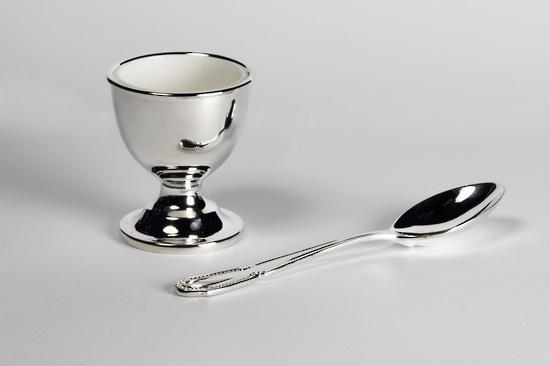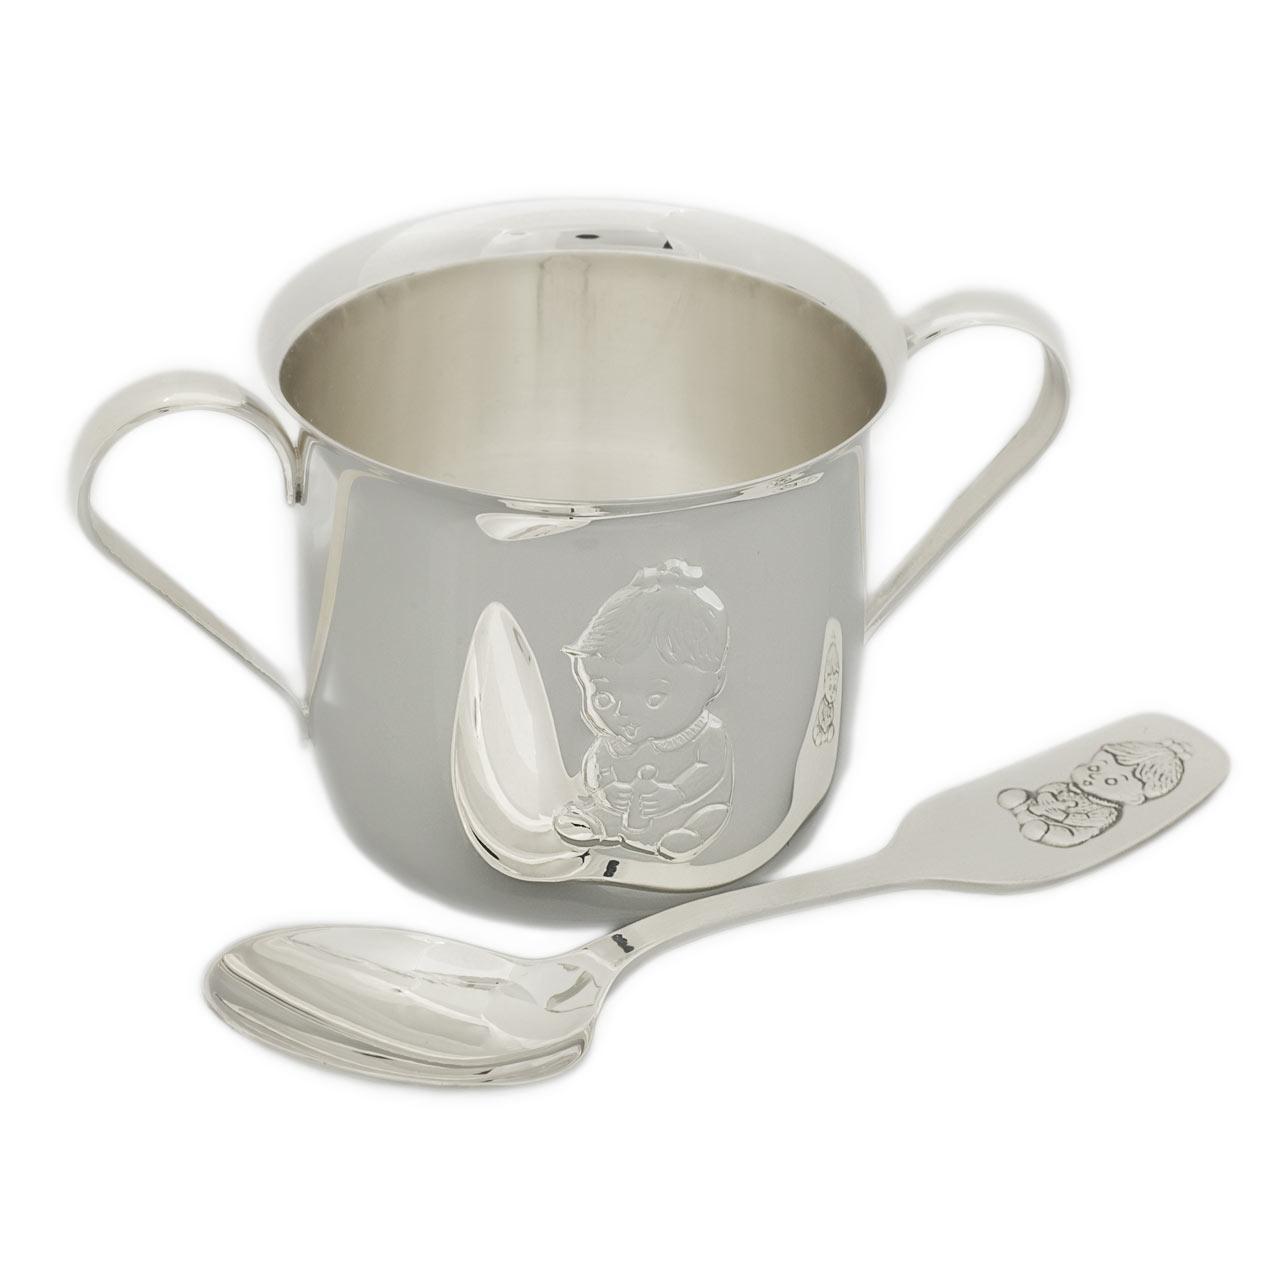The first image is the image on the left, the second image is the image on the right. Given the left and right images, does the statement "Measuring spoons and cups appear in at least one image." hold true? Answer yes or no. No. 